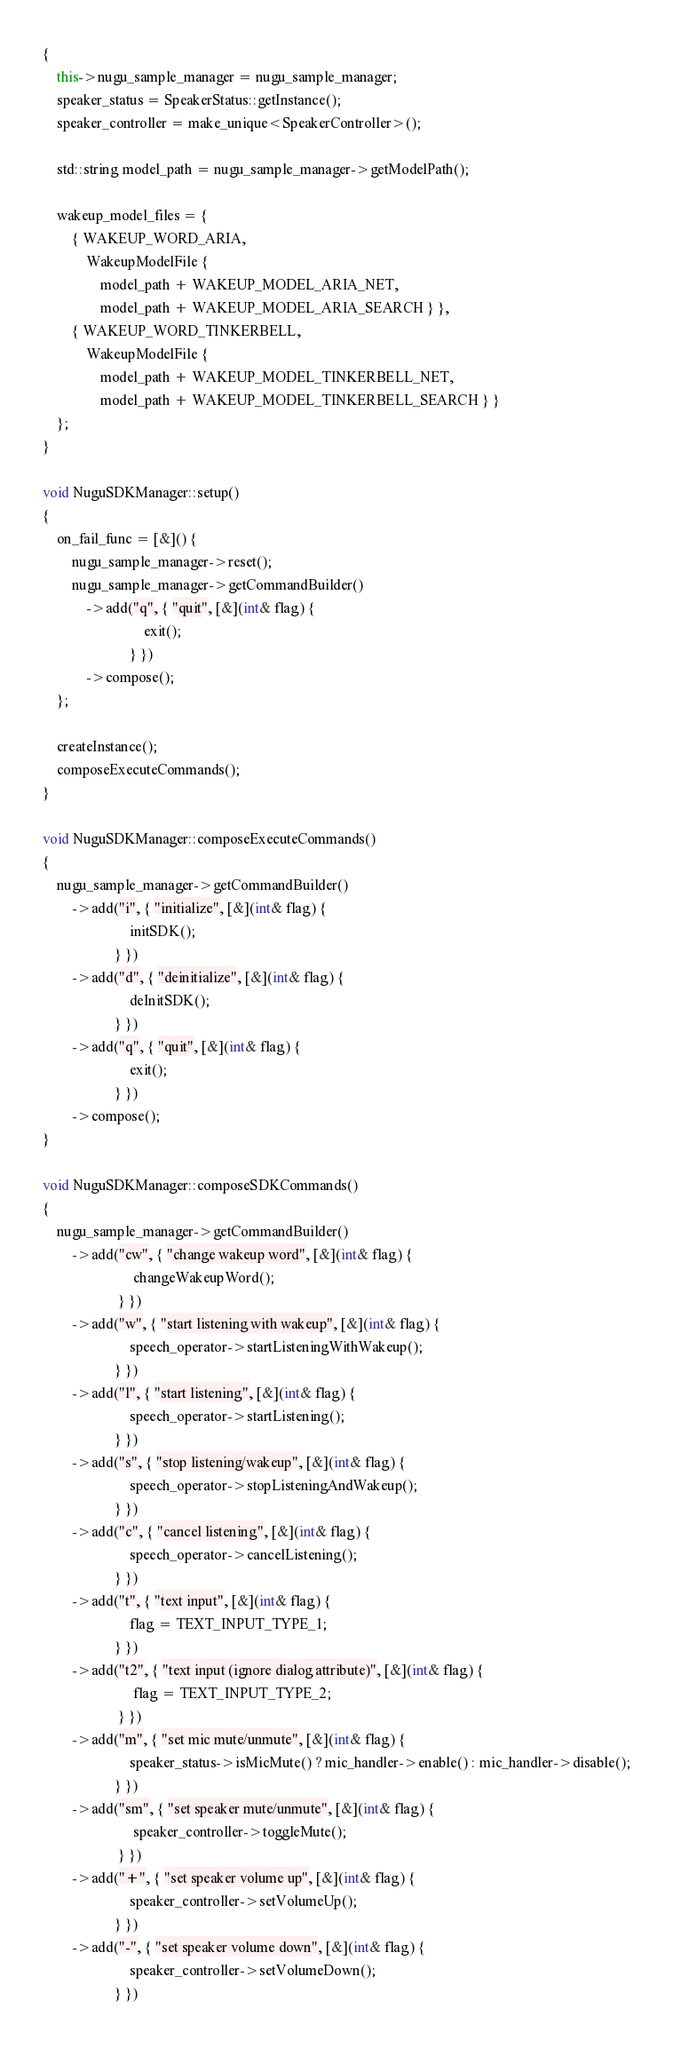Convert code to text. <code><loc_0><loc_0><loc_500><loc_500><_C++_>{
    this->nugu_sample_manager = nugu_sample_manager;
    speaker_status = SpeakerStatus::getInstance();
    speaker_controller = make_unique<SpeakerController>();

    std::string model_path = nugu_sample_manager->getModelPath();

    wakeup_model_files = {
        { WAKEUP_WORD_ARIA,
            WakeupModelFile {
                model_path + WAKEUP_MODEL_ARIA_NET,
                model_path + WAKEUP_MODEL_ARIA_SEARCH } },
        { WAKEUP_WORD_TINKERBELL,
            WakeupModelFile {
                model_path + WAKEUP_MODEL_TINKERBELL_NET,
                model_path + WAKEUP_MODEL_TINKERBELL_SEARCH } }
    };
}

void NuguSDKManager::setup()
{
    on_fail_func = [&]() {
        nugu_sample_manager->reset();
        nugu_sample_manager->getCommandBuilder()
            ->add("q", { "quit", [&](int& flag) {
                            exit();
                        } })
            ->compose();
    };

    createInstance();
    composeExecuteCommands();
}

void NuguSDKManager::composeExecuteCommands()
{
    nugu_sample_manager->getCommandBuilder()
        ->add("i", { "initialize", [&](int& flag) {
                        initSDK();
                    } })
        ->add("d", { "deinitialize", [&](int& flag) {
                        deInitSDK();
                    } })
        ->add("q", { "quit", [&](int& flag) {
                        exit();
                    } })
        ->compose();
}

void NuguSDKManager::composeSDKCommands()
{
    nugu_sample_manager->getCommandBuilder()
        ->add("cw", { "change wakeup word", [&](int& flag) {
                         changeWakeupWord();
                     } })
        ->add("w", { "start listening with wakeup", [&](int& flag) {
                        speech_operator->startListeningWithWakeup();
                    } })
        ->add("l", { "start listening", [&](int& flag) {
                        speech_operator->startListening();
                    } })
        ->add("s", { "stop listening/wakeup", [&](int& flag) {
                        speech_operator->stopListeningAndWakeup();
                    } })
        ->add("c", { "cancel listening", [&](int& flag) {
                        speech_operator->cancelListening();
                    } })
        ->add("t", { "text input", [&](int& flag) {
                        flag = TEXT_INPUT_TYPE_1;
                    } })
        ->add("t2", { "text input (ignore dialog attribute)", [&](int& flag) {
                         flag = TEXT_INPUT_TYPE_2;
                     } })
        ->add("m", { "set mic mute/unmute", [&](int& flag) {
                        speaker_status->isMicMute() ? mic_handler->enable() : mic_handler->disable();
                    } })
        ->add("sm", { "set speaker mute/unmute", [&](int& flag) {
                         speaker_controller->toggleMute();
                     } })
        ->add("+", { "set speaker volume up", [&](int& flag) {
                        speaker_controller->setVolumeUp();
                    } })
        ->add("-", { "set speaker volume down", [&](int& flag) {
                        speaker_controller->setVolumeDown();
                    } })</code> 